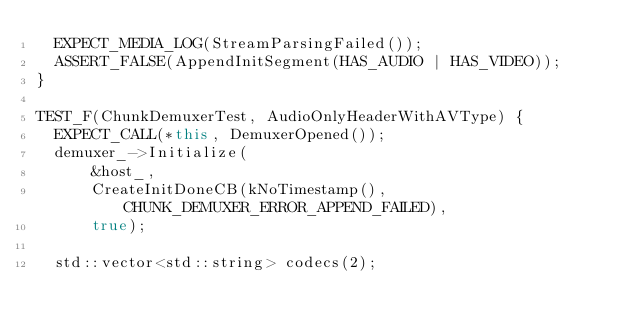Convert code to text. <code><loc_0><loc_0><loc_500><loc_500><_C++_>  EXPECT_MEDIA_LOG(StreamParsingFailed());
  ASSERT_FALSE(AppendInitSegment(HAS_AUDIO | HAS_VIDEO));
}

TEST_F(ChunkDemuxerTest, AudioOnlyHeaderWithAVType) {
  EXPECT_CALL(*this, DemuxerOpened());
  demuxer_->Initialize(
      &host_,
      CreateInitDoneCB(kNoTimestamp(), CHUNK_DEMUXER_ERROR_APPEND_FAILED),
      true);

  std::vector<std::string> codecs(2);</code> 